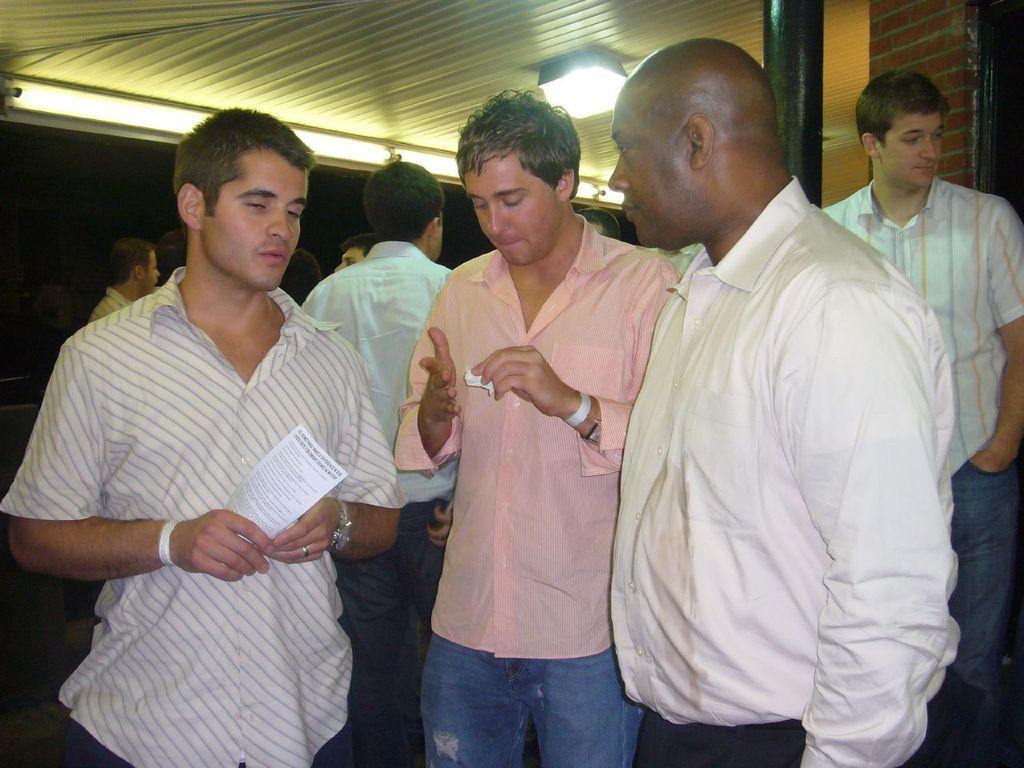Could you give a brief overview of what you see in this image? This image consists of so many persons. They are standing. The one who is on the front is holding a paper. There is light at the top. 